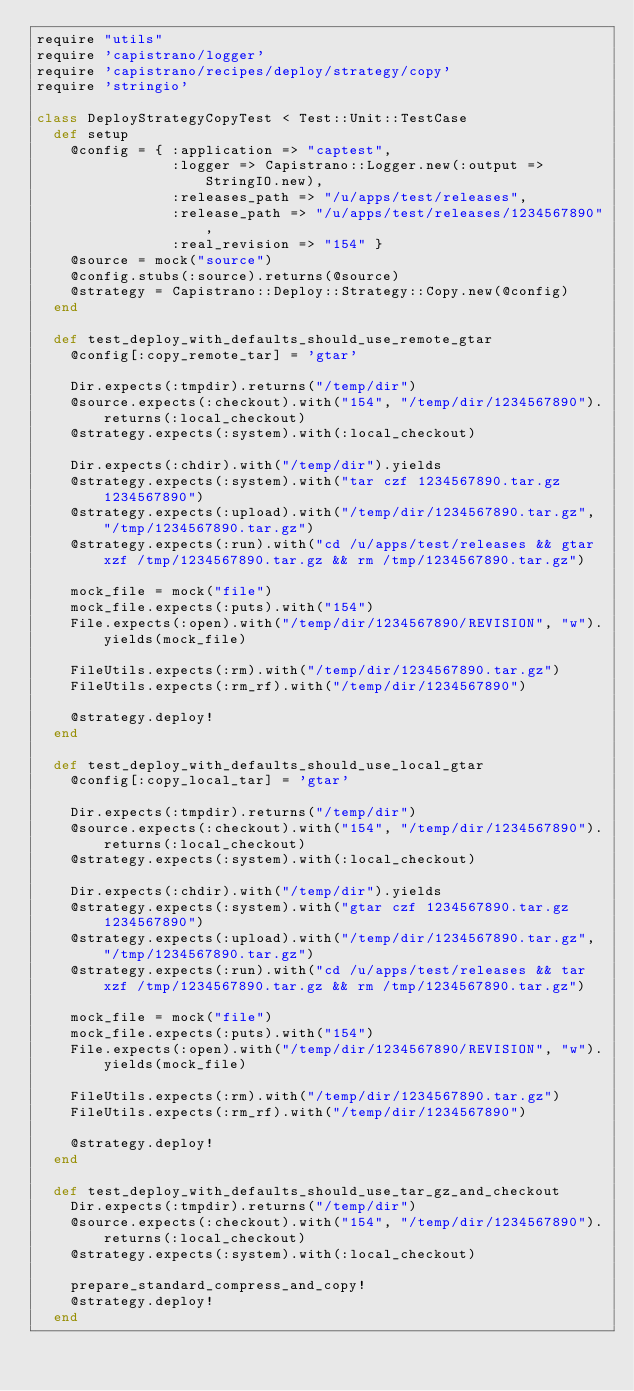Convert code to text. <code><loc_0><loc_0><loc_500><loc_500><_Ruby_>require "utils"
require 'capistrano/logger'
require 'capistrano/recipes/deploy/strategy/copy'
require 'stringio'

class DeployStrategyCopyTest < Test::Unit::TestCase
  def setup
    @config = { :application => "captest",
                :logger => Capistrano::Logger.new(:output => StringIO.new),
                :releases_path => "/u/apps/test/releases",
                :release_path => "/u/apps/test/releases/1234567890",
                :real_revision => "154" }
    @source = mock("source")
    @config.stubs(:source).returns(@source)
    @strategy = Capistrano::Deploy::Strategy::Copy.new(@config)
  end
  
  def test_deploy_with_defaults_should_use_remote_gtar
    @config[:copy_remote_tar] = 'gtar'
    
    Dir.expects(:tmpdir).returns("/temp/dir")
    @source.expects(:checkout).with("154", "/temp/dir/1234567890").returns(:local_checkout)
    @strategy.expects(:system).with(:local_checkout)

    Dir.expects(:chdir).with("/temp/dir").yields
    @strategy.expects(:system).with("tar czf 1234567890.tar.gz 1234567890")
    @strategy.expects(:upload).with("/temp/dir/1234567890.tar.gz", "/tmp/1234567890.tar.gz")
    @strategy.expects(:run).with("cd /u/apps/test/releases && gtar xzf /tmp/1234567890.tar.gz && rm /tmp/1234567890.tar.gz")

    mock_file = mock("file")
    mock_file.expects(:puts).with("154")
    File.expects(:open).with("/temp/dir/1234567890/REVISION", "w").yields(mock_file)

    FileUtils.expects(:rm).with("/temp/dir/1234567890.tar.gz")
    FileUtils.expects(:rm_rf).with("/temp/dir/1234567890")
    
    @strategy.deploy!
  end
  
  def test_deploy_with_defaults_should_use_local_gtar
    @config[:copy_local_tar] = 'gtar'
    
    Dir.expects(:tmpdir).returns("/temp/dir")
    @source.expects(:checkout).with("154", "/temp/dir/1234567890").returns(:local_checkout)
    @strategy.expects(:system).with(:local_checkout)

    Dir.expects(:chdir).with("/temp/dir").yields
    @strategy.expects(:system).with("gtar czf 1234567890.tar.gz 1234567890")
    @strategy.expects(:upload).with("/temp/dir/1234567890.tar.gz", "/tmp/1234567890.tar.gz")
    @strategy.expects(:run).with("cd /u/apps/test/releases && tar xzf /tmp/1234567890.tar.gz && rm /tmp/1234567890.tar.gz")

    mock_file = mock("file")
    mock_file.expects(:puts).with("154")
    File.expects(:open).with("/temp/dir/1234567890/REVISION", "w").yields(mock_file)

    FileUtils.expects(:rm).with("/temp/dir/1234567890.tar.gz")
    FileUtils.expects(:rm_rf).with("/temp/dir/1234567890")
    
    @strategy.deploy!
  end  

  def test_deploy_with_defaults_should_use_tar_gz_and_checkout
    Dir.expects(:tmpdir).returns("/temp/dir")
    @source.expects(:checkout).with("154", "/temp/dir/1234567890").returns(:local_checkout)
    @strategy.expects(:system).with(:local_checkout)

    prepare_standard_compress_and_copy!
    @strategy.deploy!
  end
</code> 